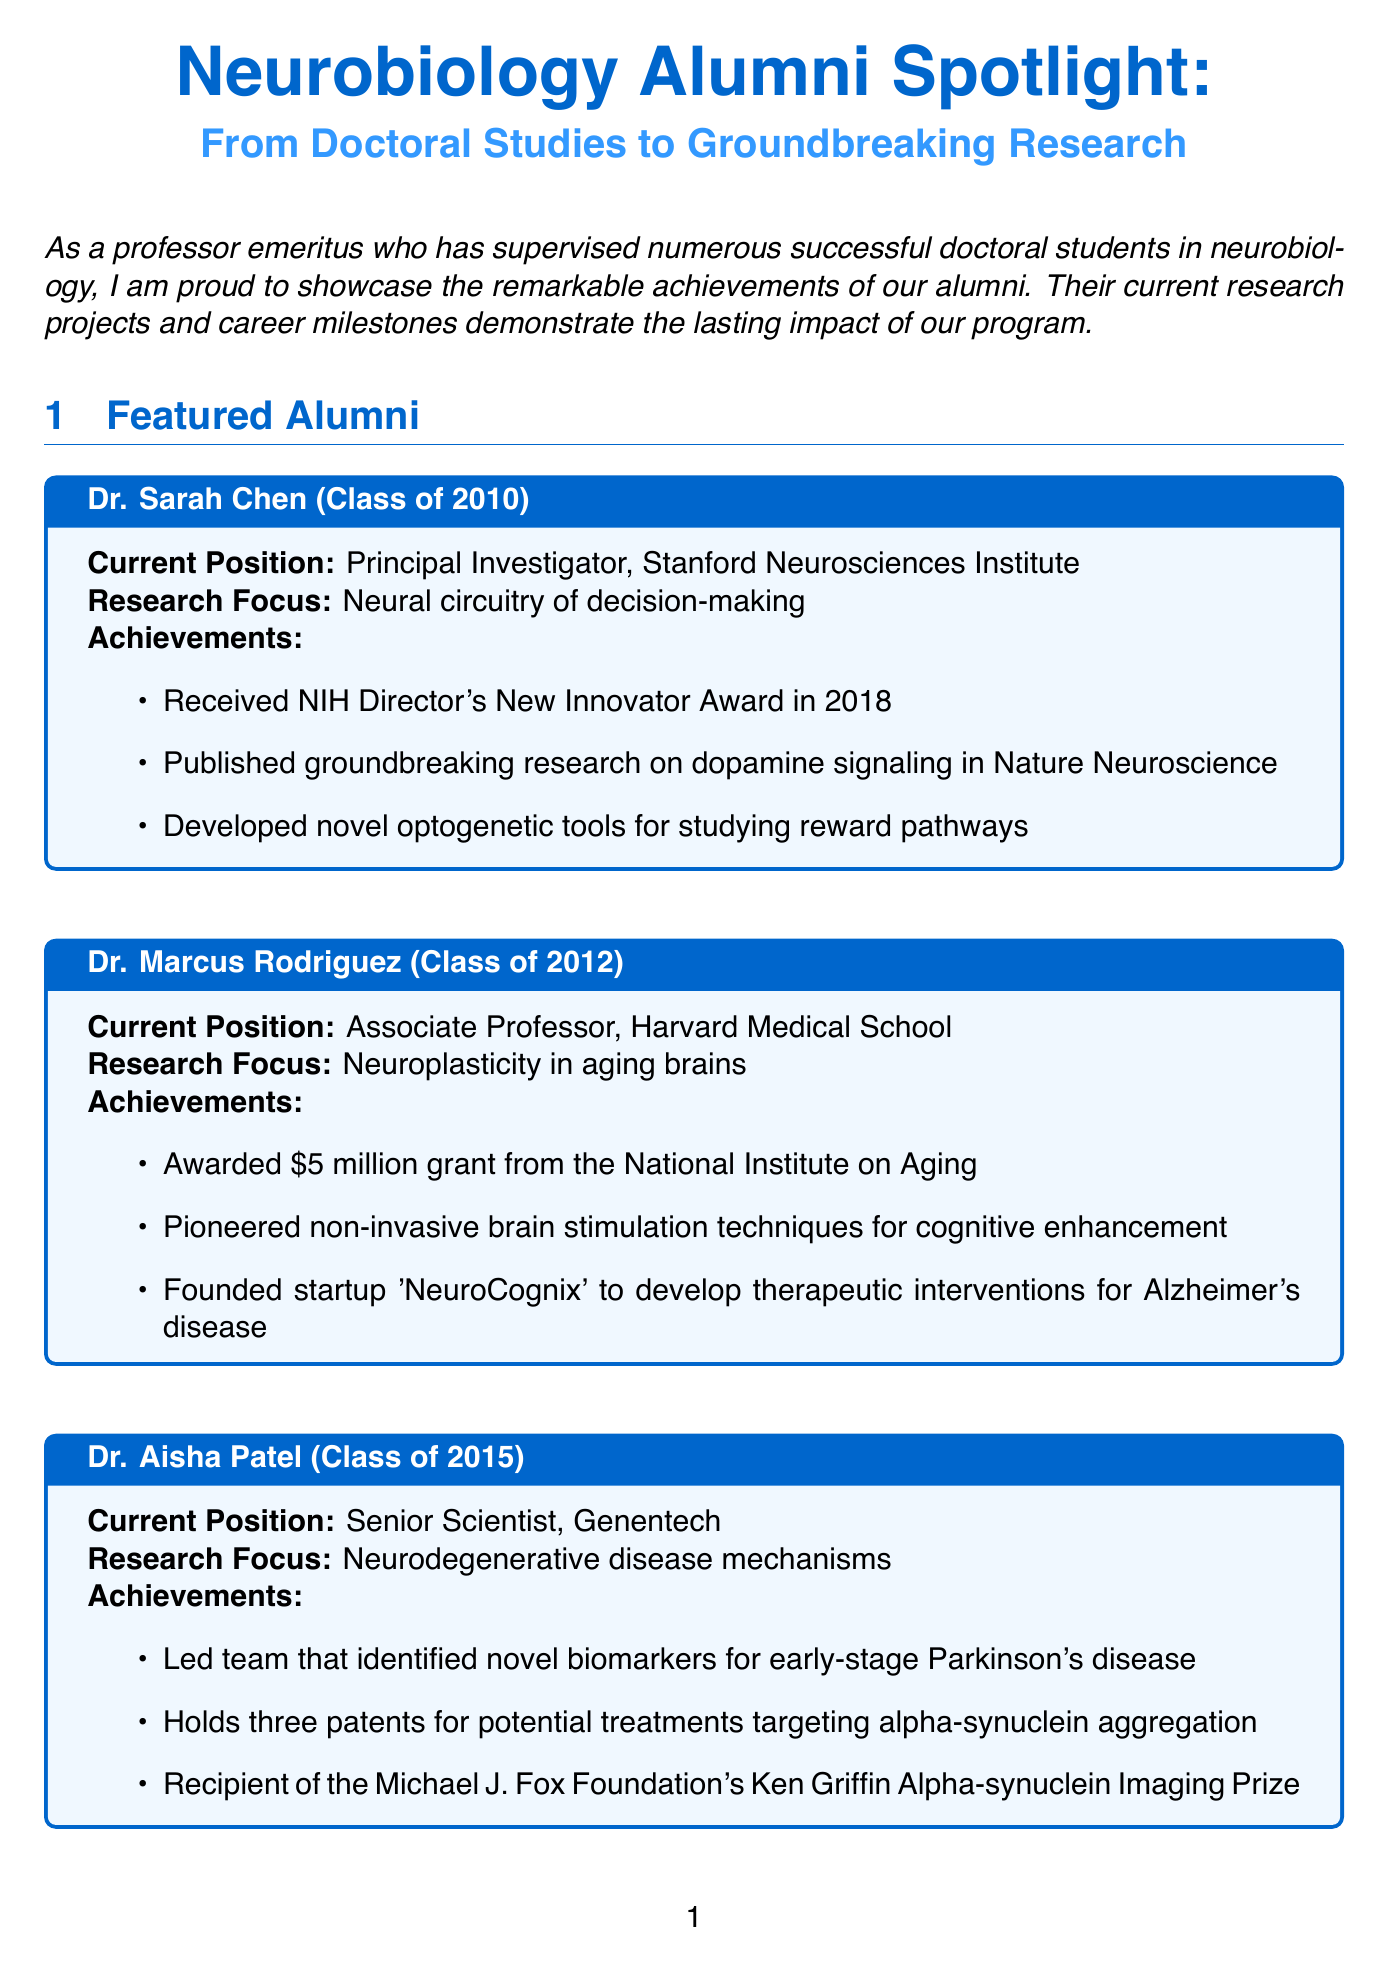What is the newsletter title? The title of the newsletter is clearly stated at the beginning of the document.
Answer: Neurobiology Alumni Spotlight: From Doctoral Studies to Groundbreaking Research Who is the keynote speaker at the Annual Neurobiology Alumni Symposium? The keynote speaker is mentioned under the upcoming events section of the document.
Answer: Dr. Aisha Patel What year did Dr. Sarah Chen graduate? Dr. Sarah Chen's graduation year is listed in her profile.
Answer: 2010 Which prestigious award did Dr. Marcus Rodriguez receive? The specific achievement related to awards is outlined in Dr. Marcus Rodriguez's achievements section.
Answer: $5 million grant from the National Institute on Aging What research focus does Dr. Aisha Patel specialize in? Dr. Aisha Patel's research focus is included in her profile in the document.
Answer: Neurodegenerative disease mechanisms How many patents does Dr. Aisha Patel hold? The number of patents held by Dr. Aisha Patel is indicated in her achievements.
Answer: three What type of event is the Neuroscience Career Panel? The nature of the event is described in the upcoming events section under the Neuroscience Career Panel.
Answer: Virtual Event Which project involves Dr. Sarah Chen and Dr. John Smith? The specific collaborative project involving these participants is mentioned in the collaborative projects section.
Answer: Cross-disciplinary Initiative on Brain-Computer Interfaces 